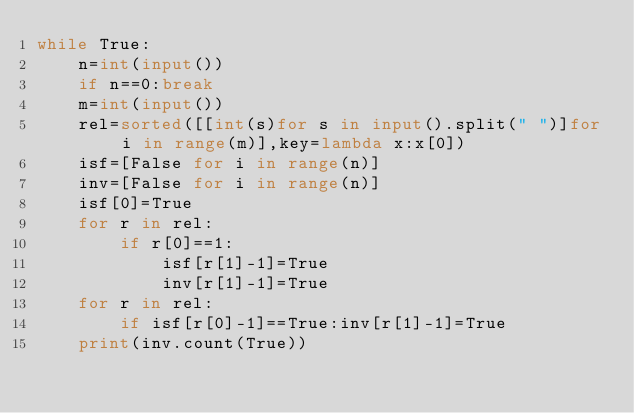Convert code to text. <code><loc_0><loc_0><loc_500><loc_500><_Python_>while True:
    n=int(input())
    if n==0:break
    m=int(input())
    rel=sorted([[int(s)for s in input().split(" ")]for i in range(m)],key=lambda x:x[0])
    isf=[False for i in range(n)]
    inv=[False for i in range(n)]
    isf[0]=True
    for r in rel:
        if r[0]==1:
            isf[r[1]-1]=True
            inv[r[1]-1]=True
    for r in rel:
        if isf[r[0]-1]==True:inv[r[1]-1]=True
    print(inv.count(True))</code> 